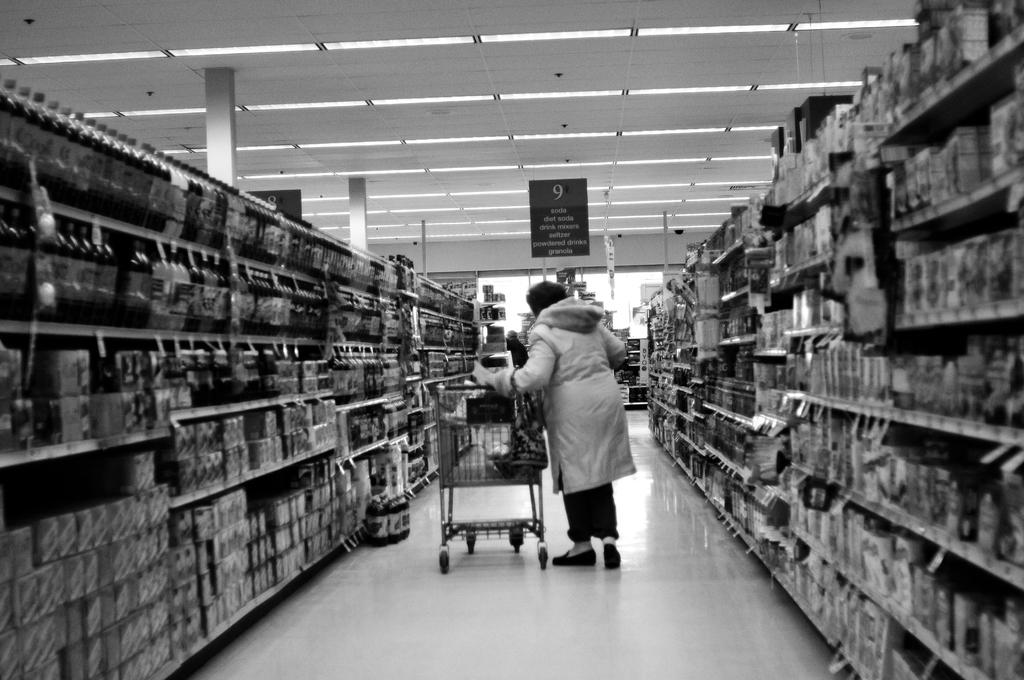<image>
Write a terse but informative summary of the picture. A woman is pushing a cart in a store under a sign that says aisle 9. 